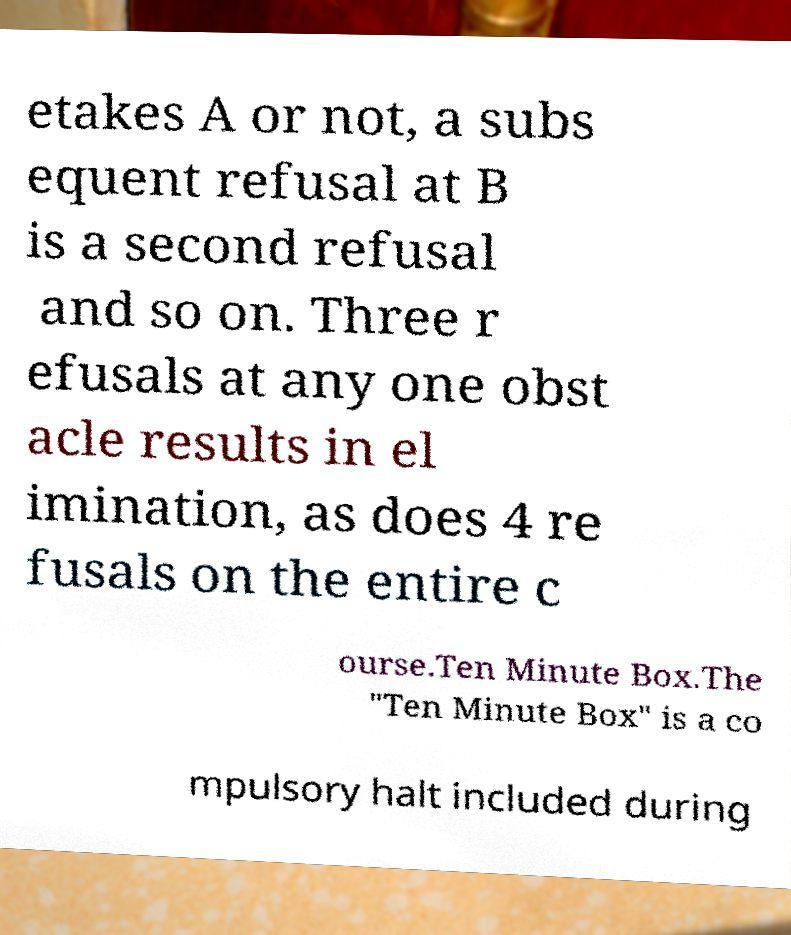What messages or text are displayed in this image? I need them in a readable, typed format. etakes A or not, a subs equent refusal at B is a second refusal and so on. Three r efusals at any one obst acle results in el imination, as does 4 re fusals on the entire c ourse.Ten Minute Box.The "Ten Minute Box" is a co mpulsory halt included during 